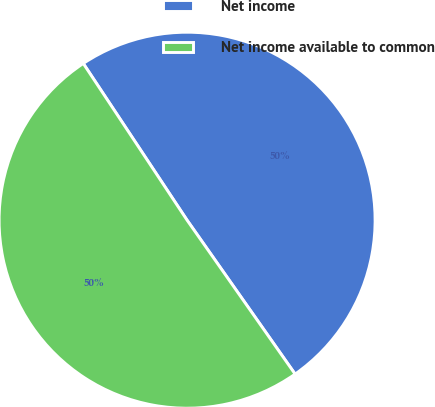<chart> <loc_0><loc_0><loc_500><loc_500><pie_chart><fcel>Net income<fcel>Net income available to common<nl><fcel>49.57%<fcel>50.43%<nl></chart> 